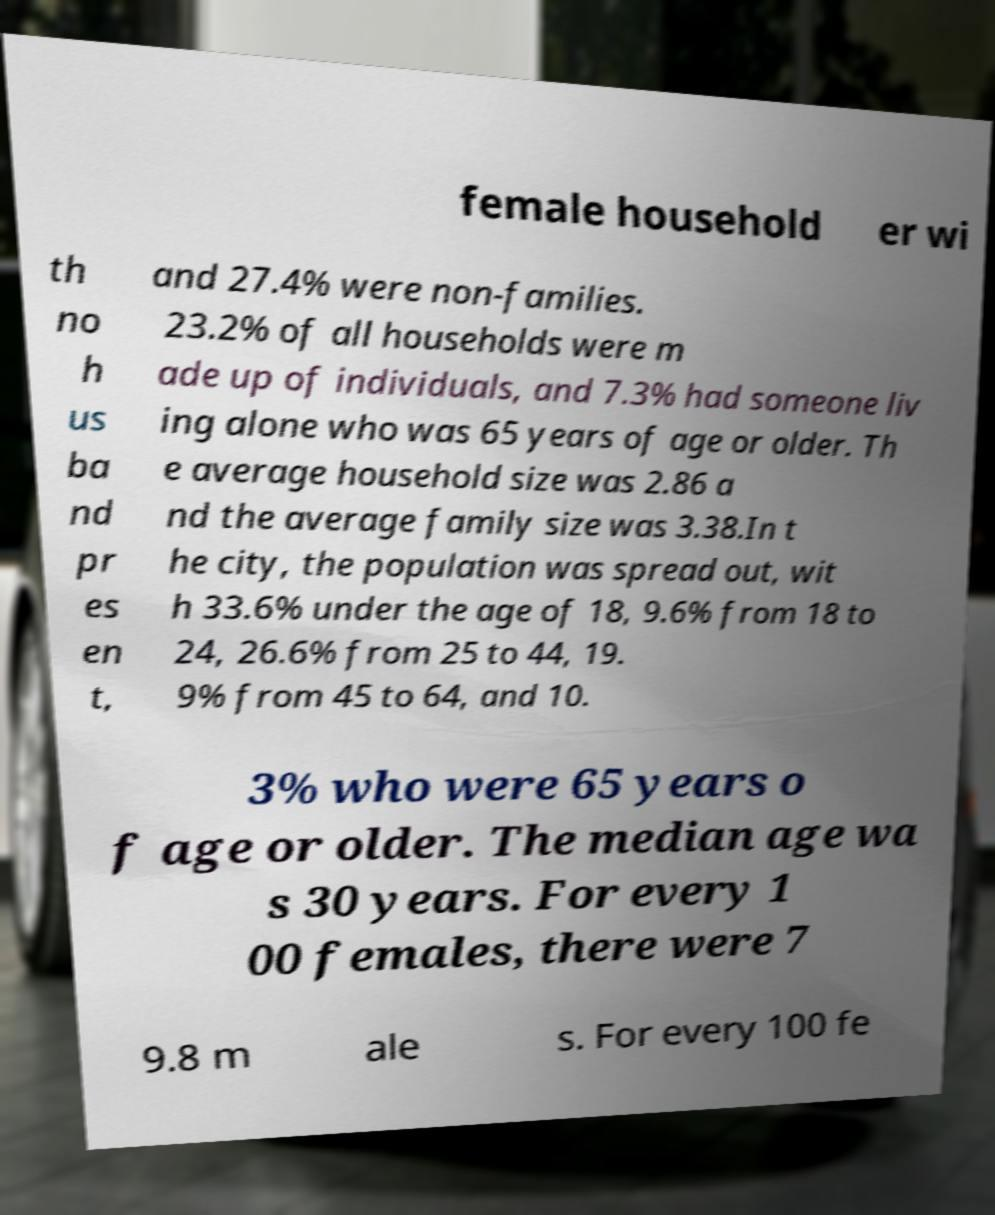Can you read and provide the text displayed in the image?This photo seems to have some interesting text. Can you extract and type it out for me? female household er wi th no h us ba nd pr es en t, and 27.4% were non-families. 23.2% of all households were m ade up of individuals, and 7.3% had someone liv ing alone who was 65 years of age or older. Th e average household size was 2.86 a nd the average family size was 3.38.In t he city, the population was spread out, wit h 33.6% under the age of 18, 9.6% from 18 to 24, 26.6% from 25 to 44, 19. 9% from 45 to 64, and 10. 3% who were 65 years o f age or older. The median age wa s 30 years. For every 1 00 females, there were 7 9.8 m ale s. For every 100 fe 